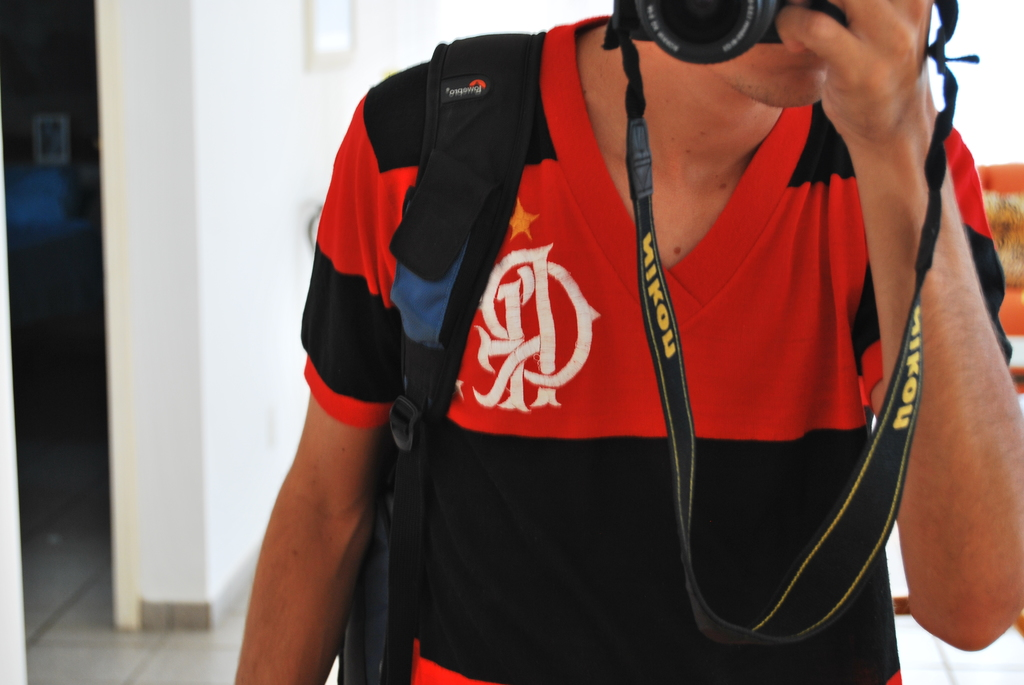What might the photographer be focusing on in this image? The photographer seems to be capturing a scene directly in front of him, likely focusing on capturing the intricate details or actions happening within his immediate vicinity, possibly a dynamic event or personal moment. What emotions might this kind of photography evoke in a viewer? This style of up-close photography can evoke a sense of intimacy and immediacy, making viewers feel as if they are part of the scene, experiencing the moment as it unfolds. 